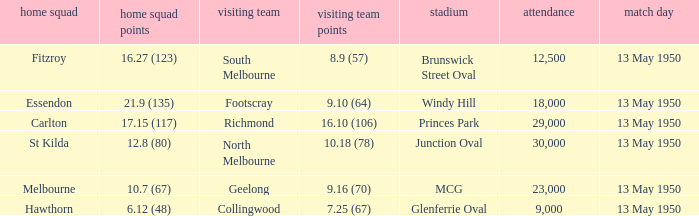Who was the away team that played Fitzroy on May 13, 1950 at Brunswick Street Oval. South Melbourne. 